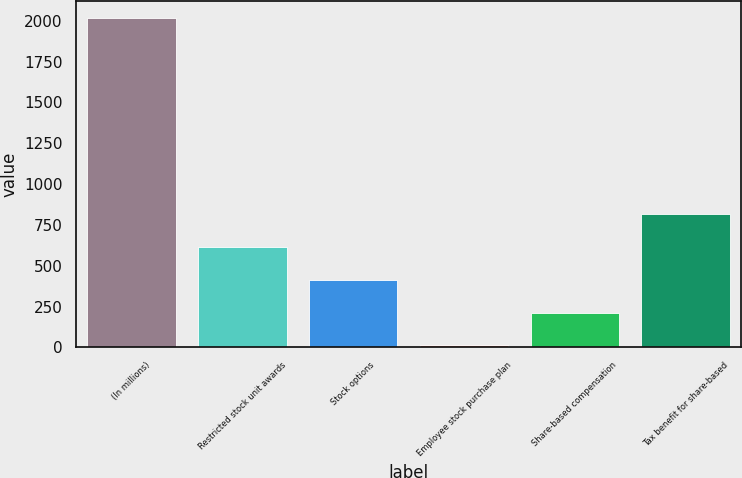<chart> <loc_0><loc_0><loc_500><loc_500><bar_chart><fcel>(In millions)<fcel>Restricted stock unit awards<fcel>Stock options<fcel>Employee stock purchase plan<fcel>Share-based compensation<fcel>Tax benefit for share-based<nl><fcel>2017<fcel>613.5<fcel>413<fcel>12<fcel>212.5<fcel>814<nl></chart> 